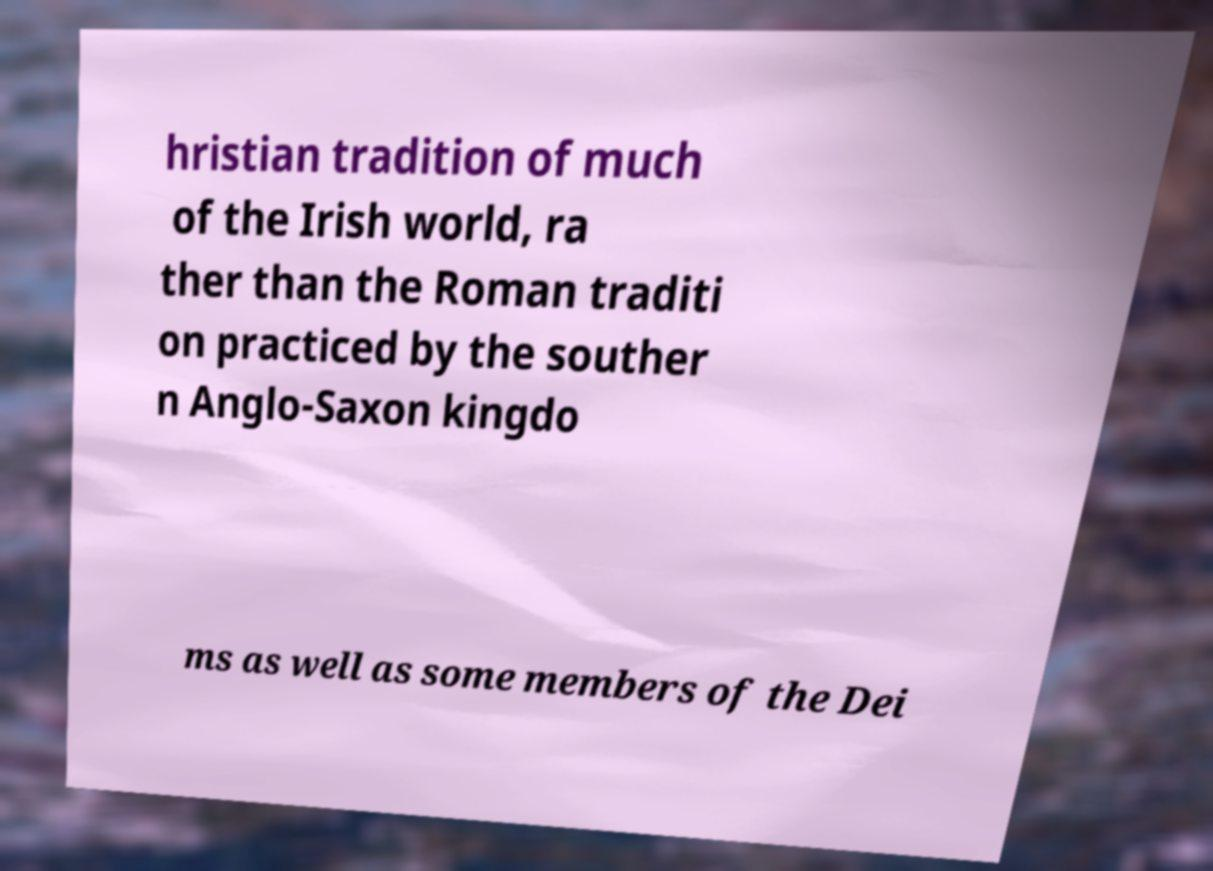What messages or text are displayed in this image? I need them in a readable, typed format. hristian tradition of much of the Irish world, ra ther than the Roman traditi on practiced by the souther n Anglo-Saxon kingdo ms as well as some members of the Dei 